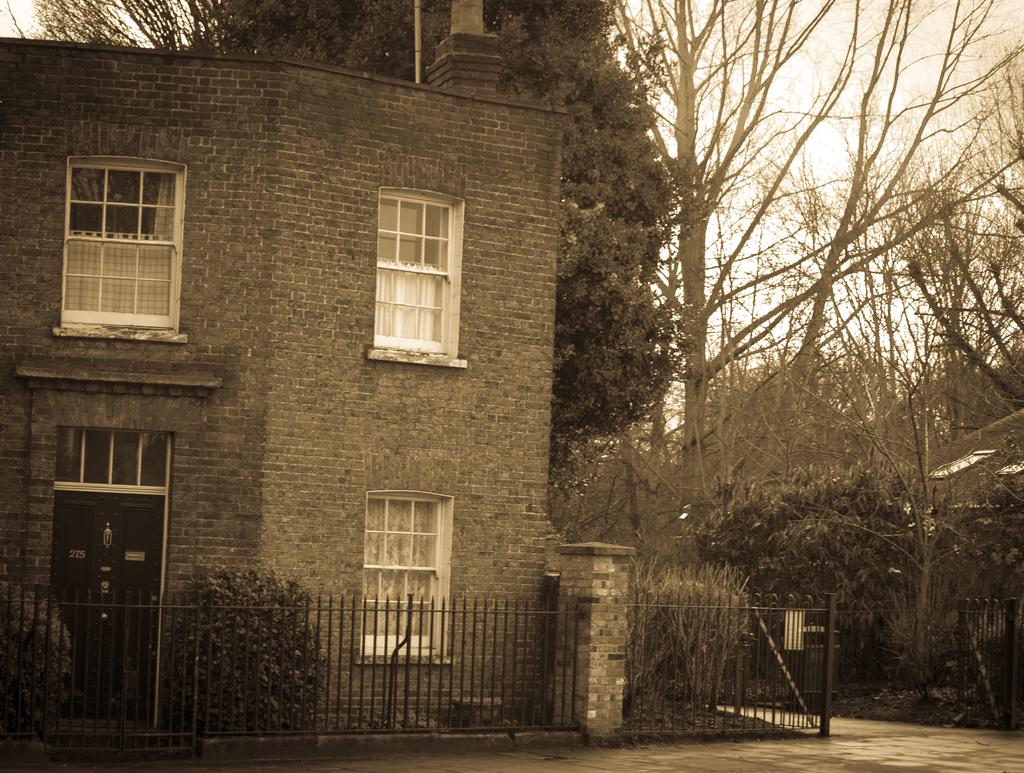What type of structure is visible in the image? There is a house in the image. What can be seen near the house? There are trees beside the house. Is there any barrier or enclosure in the image? Yes, there is a fence in the image. What type of trousers is the expert wearing while using the sponge in the image? There is no expert or sponge present in the image, and therefore no one is wearing trousers or using a sponge. 